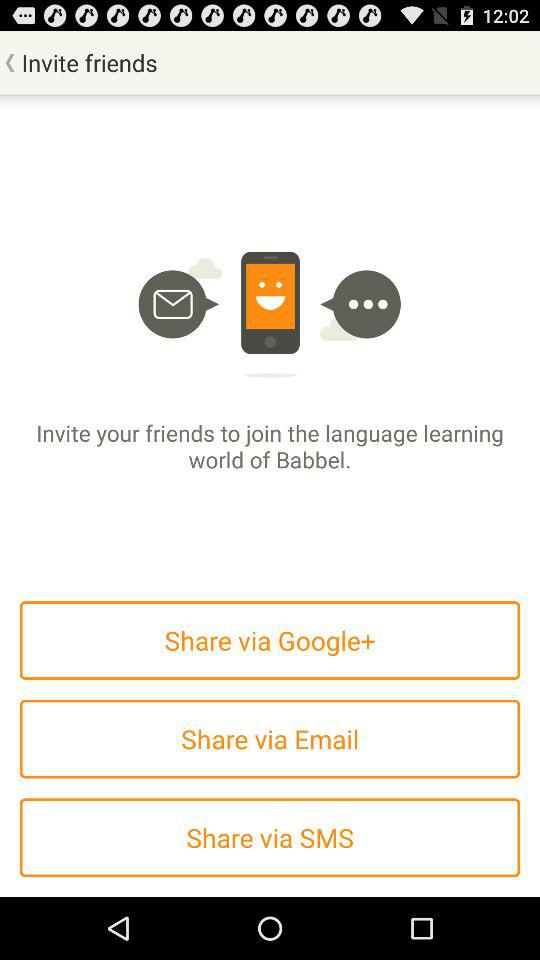What are the sharing options given there? The sharing options are "Google+", "Email" and "SMS". 